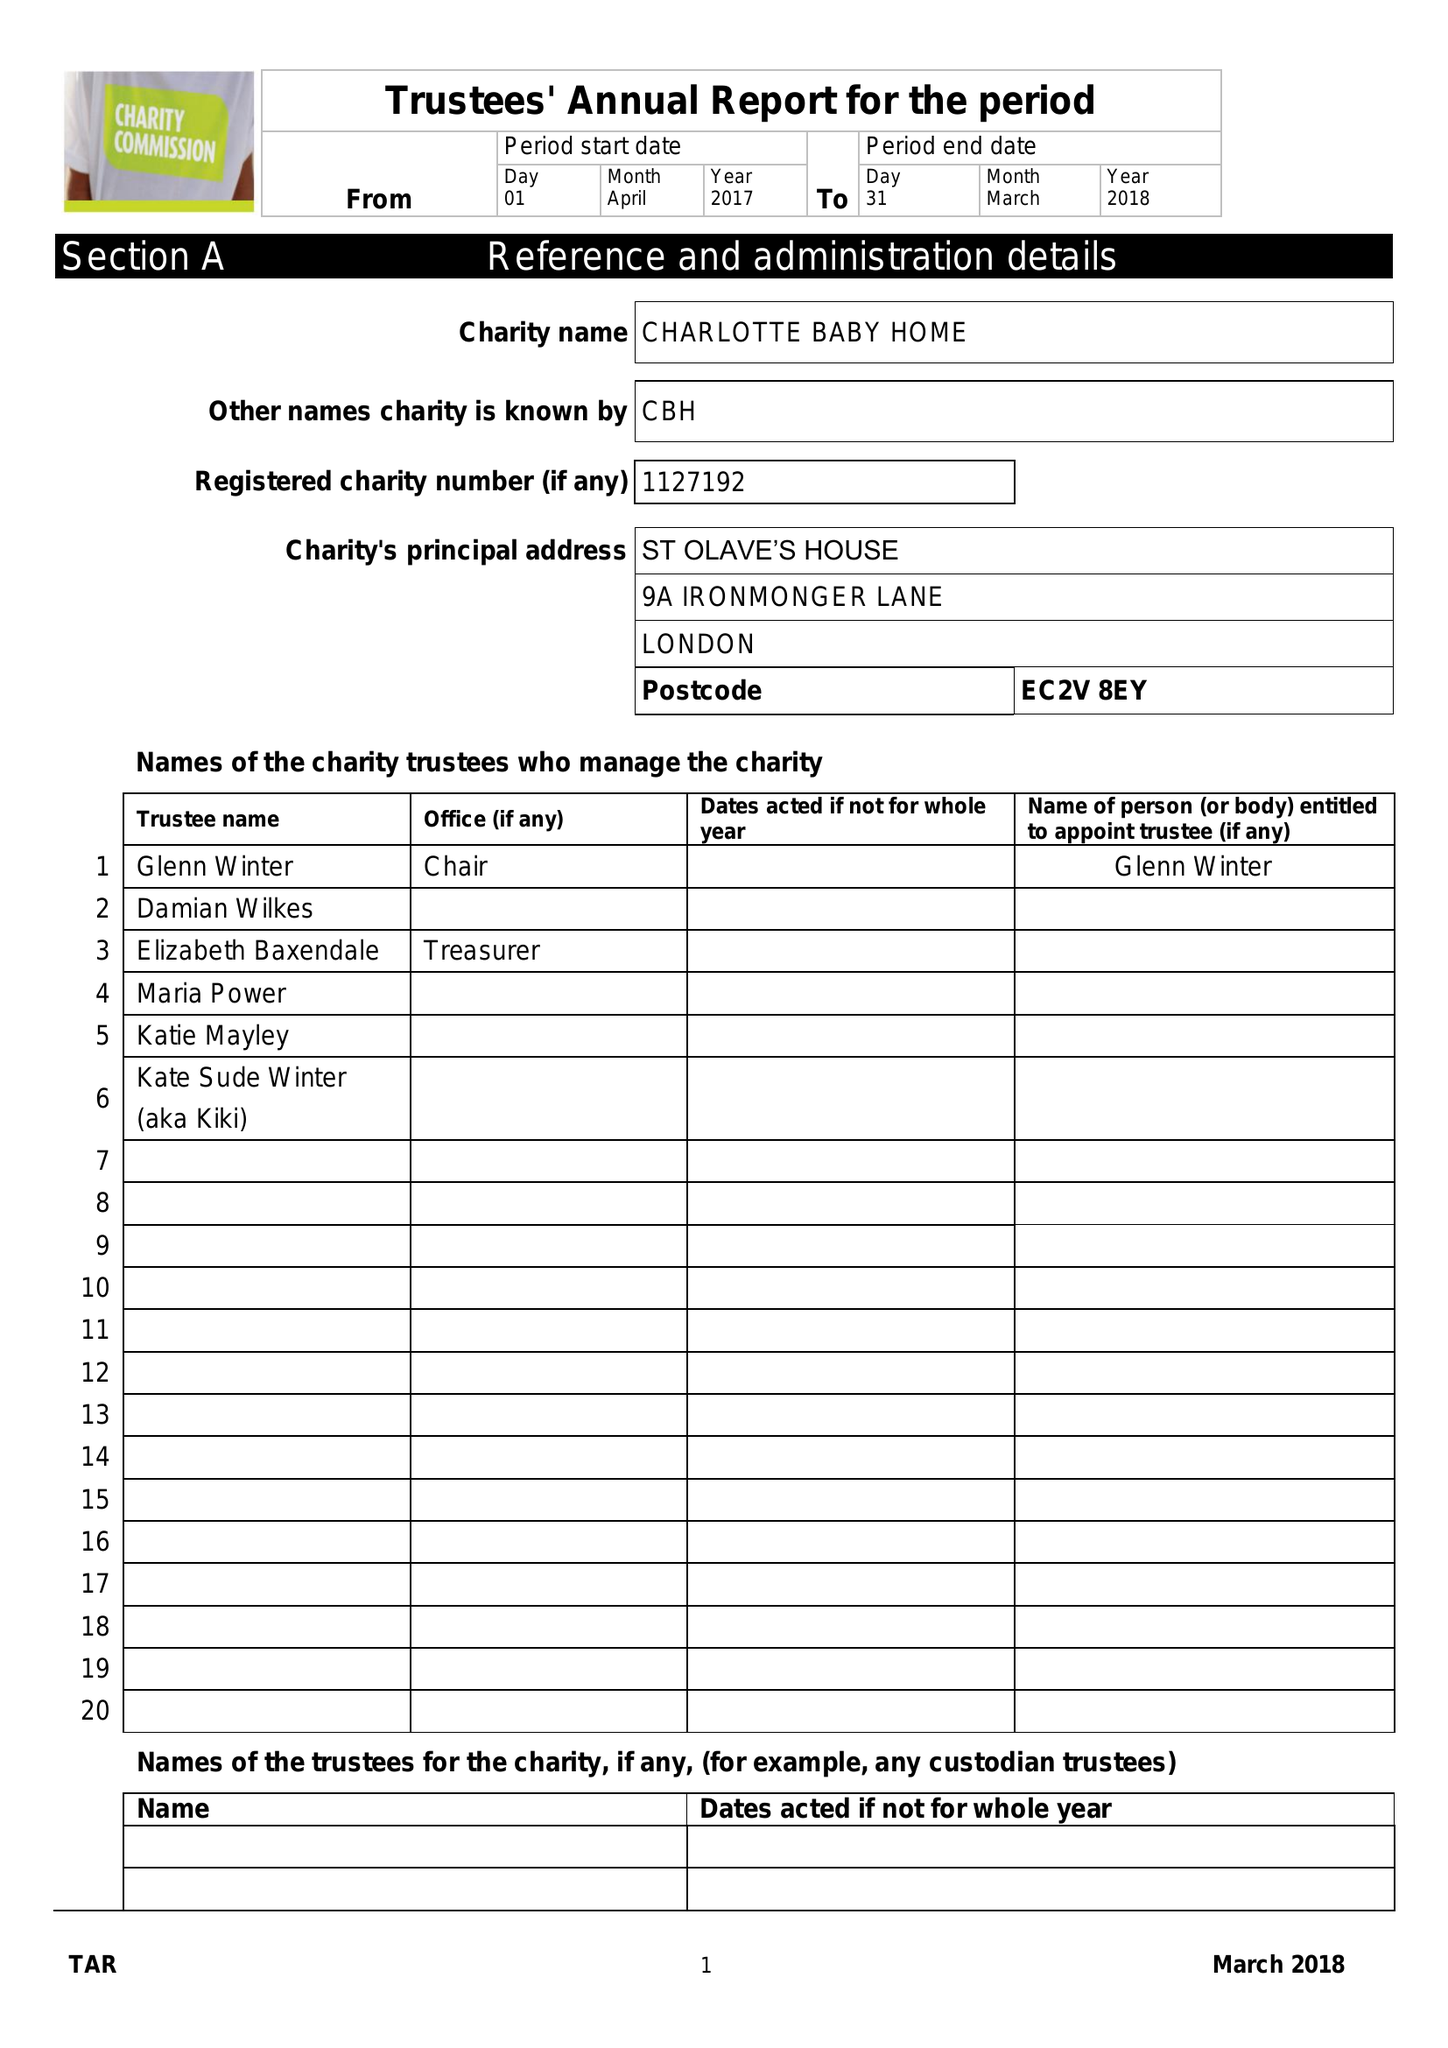What is the value for the address__post_town?
Answer the question using a single word or phrase. LONDON 